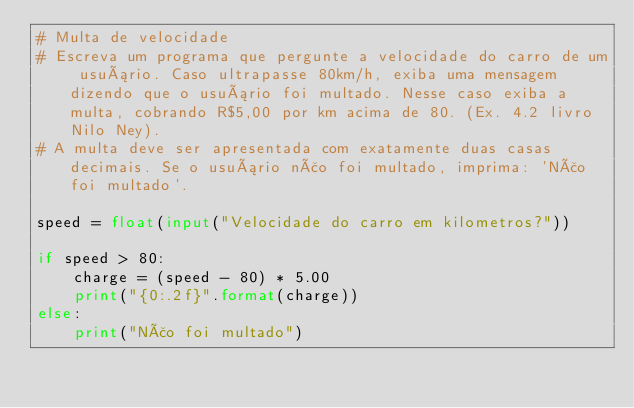<code> <loc_0><loc_0><loc_500><loc_500><_Python_># Multa de velocidade
# Escreva um programa que pergunte a velocidade do carro de um usuário. Caso ultrapasse 80km/h, exiba uma mensagem dizendo que o usuário foi multado. Nesse caso exiba a multa, cobrando R$5,00 por km acima de 80. (Ex. 4.2 livro Nilo Ney).
# A multa deve ser apresentada com exatamente duas casas decimais. Se o usuário não foi multado, imprima: 'Não foi multado'.

speed = float(input("Velocidade do carro em kilometros?"))

if speed > 80:
    charge = (speed - 80) * 5.00
    print("{0:.2f}".format(charge))
else:
    print("Não foi multado")
</code> 